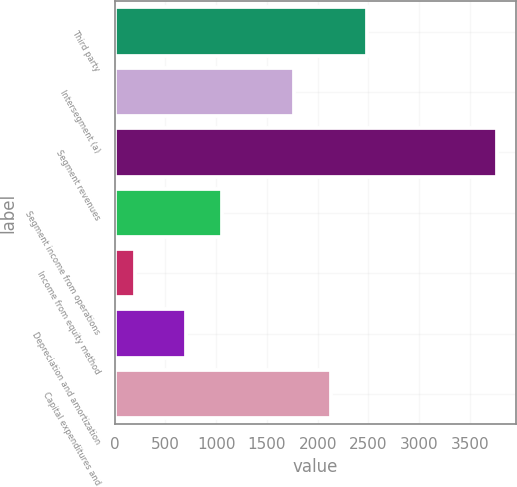Convert chart to OTSL. <chart><loc_0><loc_0><loc_500><loc_500><bar_chart><fcel>Third party<fcel>Intersegment (a)<fcel>Segment revenues<fcel>Segment income from operations<fcel>Income from equity method<fcel>Depreciation and amortization<fcel>Capital expenditures and<nl><fcel>2483<fcel>1769.4<fcel>3765<fcel>1055.8<fcel>197<fcel>699<fcel>2126.2<nl></chart> 